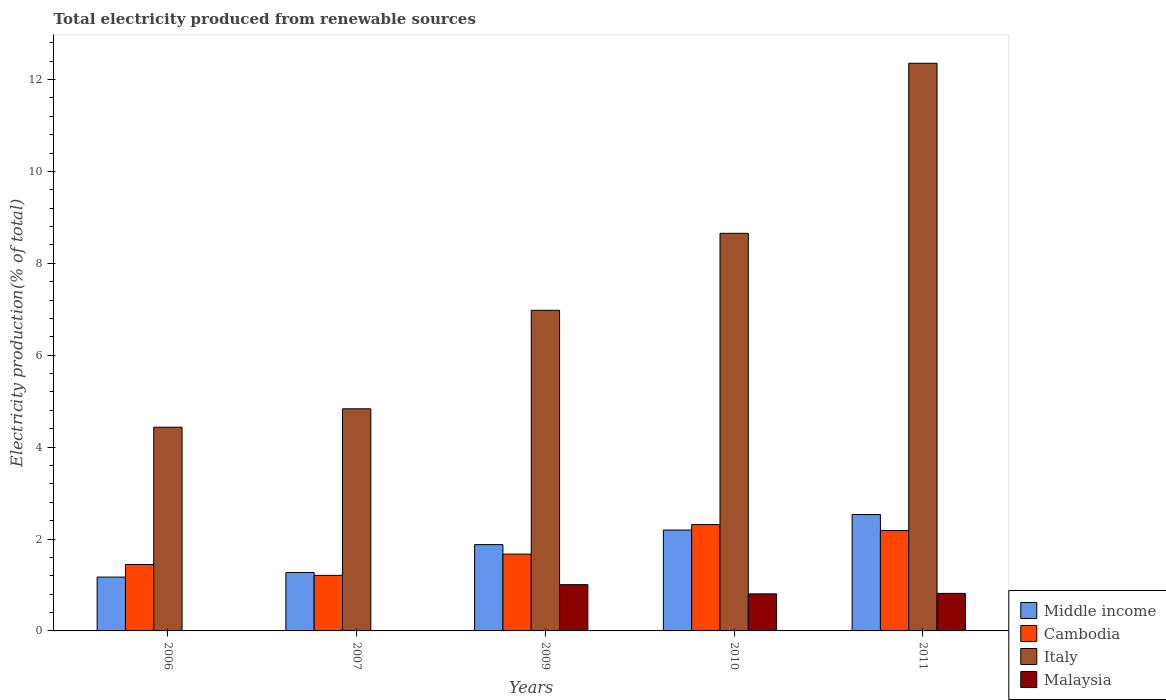How many different coloured bars are there?
Keep it short and to the point. 4. Are the number of bars on each tick of the X-axis equal?
Your answer should be very brief. Yes. How many bars are there on the 4th tick from the right?
Offer a terse response. 4. In how many cases, is the number of bars for a given year not equal to the number of legend labels?
Give a very brief answer. 0. What is the total electricity produced in Italy in 2010?
Offer a very short reply. 8.65. Across all years, what is the maximum total electricity produced in Italy?
Make the answer very short. 12.35. Across all years, what is the minimum total electricity produced in Malaysia?
Offer a terse response. 0. In which year was the total electricity produced in Middle income maximum?
Your answer should be compact. 2011. In which year was the total electricity produced in Cambodia minimum?
Your answer should be compact. 2007. What is the total total electricity produced in Italy in the graph?
Ensure brevity in your answer.  37.25. What is the difference between the total electricity produced in Malaysia in 2006 and that in 2009?
Offer a terse response. -1.01. What is the difference between the total electricity produced in Italy in 2011 and the total electricity produced in Cambodia in 2007?
Keep it short and to the point. 11.14. What is the average total electricity produced in Malaysia per year?
Give a very brief answer. 0.53. In the year 2009, what is the difference between the total electricity produced in Middle income and total electricity produced in Malaysia?
Give a very brief answer. 0.87. In how many years, is the total electricity produced in Middle income greater than 9.6 %?
Give a very brief answer. 0. What is the ratio of the total electricity produced in Cambodia in 2006 to that in 2010?
Provide a succinct answer. 0.62. Is the total electricity produced in Cambodia in 2009 less than that in 2010?
Your answer should be compact. Yes. What is the difference between the highest and the second highest total electricity produced in Middle income?
Offer a very short reply. 0.34. What is the difference between the highest and the lowest total electricity produced in Italy?
Give a very brief answer. 7.92. Is it the case that in every year, the sum of the total electricity produced in Italy and total electricity produced in Middle income is greater than the sum of total electricity produced in Malaysia and total electricity produced in Cambodia?
Your response must be concise. Yes. What does the 2nd bar from the left in 2006 represents?
Make the answer very short. Cambodia. What does the 4th bar from the right in 2007 represents?
Your answer should be very brief. Middle income. Is it the case that in every year, the sum of the total electricity produced in Middle income and total electricity produced in Italy is greater than the total electricity produced in Cambodia?
Provide a succinct answer. Yes. How many bars are there?
Offer a very short reply. 20. Are all the bars in the graph horizontal?
Offer a terse response. No. How many years are there in the graph?
Provide a succinct answer. 5. What is the difference between two consecutive major ticks on the Y-axis?
Provide a succinct answer. 2. Does the graph contain grids?
Your answer should be very brief. No. How many legend labels are there?
Your answer should be compact. 4. How are the legend labels stacked?
Your answer should be very brief. Vertical. What is the title of the graph?
Ensure brevity in your answer.  Total electricity produced from renewable sources. Does "Cote d'Ivoire" appear as one of the legend labels in the graph?
Offer a terse response. No. What is the Electricity production(% of total) in Middle income in 2006?
Offer a very short reply. 1.17. What is the Electricity production(% of total) of Cambodia in 2006?
Your response must be concise. 1.45. What is the Electricity production(% of total) of Italy in 2006?
Offer a terse response. 4.43. What is the Electricity production(% of total) of Malaysia in 2006?
Your answer should be very brief. 0. What is the Electricity production(% of total) in Middle income in 2007?
Keep it short and to the point. 1.27. What is the Electricity production(% of total) of Cambodia in 2007?
Your answer should be very brief. 1.21. What is the Electricity production(% of total) of Italy in 2007?
Keep it short and to the point. 4.83. What is the Electricity production(% of total) in Malaysia in 2007?
Make the answer very short. 0. What is the Electricity production(% of total) of Middle income in 2009?
Your response must be concise. 1.88. What is the Electricity production(% of total) in Cambodia in 2009?
Your response must be concise. 1.67. What is the Electricity production(% of total) of Italy in 2009?
Your response must be concise. 6.98. What is the Electricity production(% of total) of Malaysia in 2009?
Give a very brief answer. 1.01. What is the Electricity production(% of total) in Middle income in 2010?
Your answer should be compact. 2.2. What is the Electricity production(% of total) of Cambodia in 2010?
Provide a succinct answer. 2.31. What is the Electricity production(% of total) of Italy in 2010?
Offer a very short reply. 8.65. What is the Electricity production(% of total) of Malaysia in 2010?
Your answer should be very brief. 0.81. What is the Electricity production(% of total) in Middle income in 2011?
Your answer should be very brief. 2.53. What is the Electricity production(% of total) of Cambodia in 2011?
Provide a short and direct response. 2.18. What is the Electricity production(% of total) in Italy in 2011?
Provide a succinct answer. 12.35. What is the Electricity production(% of total) of Malaysia in 2011?
Your answer should be compact. 0.82. Across all years, what is the maximum Electricity production(% of total) in Middle income?
Offer a terse response. 2.53. Across all years, what is the maximum Electricity production(% of total) in Cambodia?
Ensure brevity in your answer.  2.31. Across all years, what is the maximum Electricity production(% of total) in Italy?
Your answer should be very brief. 12.35. Across all years, what is the maximum Electricity production(% of total) of Malaysia?
Your answer should be very brief. 1.01. Across all years, what is the minimum Electricity production(% of total) of Middle income?
Your response must be concise. 1.17. Across all years, what is the minimum Electricity production(% of total) of Cambodia?
Offer a very short reply. 1.21. Across all years, what is the minimum Electricity production(% of total) of Italy?
Offer a very short reply. 4.43. Across all years, what is the minimum Electricity production(% of total) in Malaysia?
Your answer should be compact. 0. What is the total Electricity production(% of total) in Middle income in the graph?
Provide a succinct answer. 9.05. What is the total Electricity production(% of total) in Cambodia in the graph?
Provide a short and direct response. 8.82. What is the total Electricity production(% of total) in Italy in the graph?
Ensure brevity in your answer.  37.25. What is the total Electricity production(% of total) in Malaysia in the graph?
Offer a very short reply. 2.63. What is the difference between the Electricity production(% of total) of Middle income in 2006 and that in 2007?
Provide a succinct answer. -0.1. What is the difference between the Electricity production(% of total) in Cambodia in 2006 and that in 2007?
Offer a terse response. 0.24. What is the difference between the Electricity production(% of total) in Italy in 2006 and that in 2007?
Keep it short and to the point. -0.4. What is the difference between the Electricity production(% of total) of Malaysia in 2006 and that in 2007?
Offer a terse response. 0. What is the difference between the Electricity production(% of total) in Middle income in 2006 and that in 2009?
Your response must be concise. -0.71. What is the difference between the Electricity production(% of total) in Cambodia in 2006 and that in 2009?
Your answer should be very brief. -0.23. What is the difference between the Electricity production(% of total) of Italy in 2006 and that in 2009?
Keep it short and to the point. -2.54. What is the difference between the Electricity production(% of total) in Malaysia in 2006 and that in 2009?
Ensure brevity in your answer.  -1.01. What is the difference between the Electricity production(% of total) of Middle income in 2006 and that in 2010?
Provide a succinct answer. -1.02. What is the difference between the Electricity production(% of total) in Cambodia in 2006 and that in 2010?
Give a very brief answer. -0.87. What is the difference between the Electricity production(% of total) in Italy in 2006 and that in 2010?
Your response must be concise. -4.22. What is the difference between the Electricity production(% of total) in Malaysia in 2006 and that in 2010?
Your answer should be compact. -0.81. What is the difference between the Electricity production(% of total) of Middle income in 2006 and that in 2011?
Give a very brief answer. -1.36. What is the difference between the Electricity production(% of total) in Cambodia in 2006 and that in 2011?
Provide a succinct answer. -0.74. What is the difference between the Electricity production(% of total) of Italy in 2006 and that in 2011?
Your answer should be compact. -7.92. What is the difference between the Electricity production(% of total) in Malaysia in 2006 and that in 2011?
Offer a very short reply. -0.82. What is the difference between the Electricity production(% of total) in Middle income in 2007 and that in 2009?
Offer a very short reply. -0.61. What is the difference between the Electricity production(% of total) of Cambodia in 2007 and that in 2009?
Make the answer very short. -0.46. What is the difference between the Electricity production(% of total) in Italy in 2007 and that in 2009?
Give a very brief answer. -2.14. What is the difference between the Electricity production(% of total) in Malaysia in 2007 and that in 2009?
Give a very brief answer. -1.01. What is the difference between the Electricity production(% of total) in Middle income in 2007 and that in 2010?
Make the answer very short. -0.92. What is the difference between the Electricity production(% of total) in Cambodia in 2007 and that in 2010?
Your response must be concise. -1.1. What is the difference between the Electricity production(% of total) of Italy in 2007 and that in 2010?
Make the answer very short. -3.82. What is the difference between the Electricity production(% of total) of Malaysia in 2007 and that in 2010?
Your response must be concise. -0.81. What is the difference between the Electricity production(% of total) in Middle income in 2007 and that in 2011?
Provide a succinct answer. -1.26. What is the difference between the Electricity production(% of total) of Cambodia in 2007 and that in 2011?
Your response must be concise. -0.98. What is the difference between the Electricity production(% of total) of Italy in 2007 and that in 2011?
Give a very brief answer. -7.52. What is the difference between the Electricity production(% of total) of Malaysia in 2007 and that in 2011?
Your response must be concise. -0.82. What is the difference between the Electricity production(% of total) in Middle income in 2009 and that in 2010?
Offer a very short reply. -0.32. What is the difference between the Electricity production(% of total) in Cambodia in 2009 and that in 2010?
Offer a very short reply. -0.64. What is the difference between the Electricity production(% of total) in Italy in 2009 and that in 2010?
Provide a short and direct response. -1.67. What is the difference between the Electricity production(% of total) of Malaysia in 2009 and that in 2010?
Ensure brevity in your answer.  0.2. What is the difference between the Electricity production(% of total) of Middle income in 2009 and that in 2011?
Keep it short and to the point. -0.65. What is the difference between the Electricity production(% of total) in Cambodia in 2009 and that in 2011?
Offer a terse response. -0.51. What is the difference between the Electricity production(% of total) in Italy in 2009 and that in 2011?
Provide a succinct answer. -5.38. What is the difference between the Electricity production(% of total) in Malaysia in 2009 and that in 2011?
Make the answer very short. 0.19. What is the difference between the Electricity production(% of total) of Middle income in 2010 and that in 2011?
Provide a succinct answer. -0.34. What is the difference between the Electricity production(% of total) of Cambodia in 2010 and that in 2011?
Give a very brief answer. 0.13. What is the difference between the Electricity production(% of total) in Italy in 2010 and that in 2011?
Your answer should be compact. -3.7. What is the difference between the Electricity production(% of total) in Malaysia in 2010 and that in 2011?
Ensure brevity in your answer.  -0.01. What is the difference between the Electricity production(% of total) of Middle income in 2006 and the Electricity production(% of total) of Cambodia in 2007?
Provide a short and direct response. -0.04. What is the difference between the Electricity production(% of total) in Middle income in 2006 and the Electricity production(% of total) in Italy in 2007?
Your answer should be compact. -3.66. What is the difference between the Electricity production(% of total) of Middle income in 2006 and the Electricity production(% of total) of Malaysia in 2007?
Offer a very short reply. 1.17. What is the difference between the Electricity production(% of total) of Cambodia in 2006 and the Electricity production(% of total) of Italy in 2007?
Offer a very short reply. -3.39. What is the difference between the Electricity production(% of total) in Cambodia in 2006 and the Electricity production(% of total) in Malaysia in 2007?
Your answer should be compact. 1.44. What is the difference between the Electricity production(% of total) in Italy in 2006 and the Electricity production(% of total) in Malaysia in 2007?
Ensure brevity in your answer.  4.43. What is the difference between the Electricity production(% of total) in Middle income in 2006 and the Electricity production(% of total) in Cambodia in 2009?
Provide a succinct answer. -0.5. What is the difference between the Electricity production(% of total) of Middle income in 2006 and the Electricity production(% of total) of Italy in 2009?
Keep it short and to the point. -5.81. What is the difference between the Electricity production(% of total) of Middle income in 2006 and the Electricity production(% of total) of Malaysia in 2009?
Keep it short and to the point. 0.16. What is the difference between the Electricity production(% of total) of Cambodia in 2006 and the Electricity production(% of total) of Italy in 2009?
Give a very brief answer. -5.53. What is the difference between the Electricity production(% of total) in Cambodia in 2006 and the Electricity production(% of total) in Malaysia in 2009?
Your answer should be very brief. 0.44. What is the difference between the Electricity production(% of total) in Italy in 2006 and the Electricity production(% of total) in Malaysia in 2009?
Ensure brevity in your answer.  3.43. What is the difference between the Electricity production(% of total) of Middle income in 2006 and the Electricity production(% of total) of Cambodia in 2010?
Give a very brief answer. -1.14. What is the difference between the Electricity production(% of total) of Middle income in 2006 and the Electricity production(% of total) of Italy in 2010?
Your answer should be very brief. -7.48. What is the difference between the Electricity production(% of total) of Middle income in 2006 and the Electricity production(% of total) of Malaysia in 2010?
Give a very brief answer. 0.37. What is the difference between the Electricity production(% of total) of Cambodia in 2006 and the Electricity production(% of total) of Italy in 2010?
Keep it short and to the point. -7.21. What is the difference between the Electricity production(% of total) of Cambodia in 2006 and the Electricity production(% of total) of Malaysia in 2010?
Your answer should be very brief. 0.64. What is the difference between the Electricity production(% of total) in Italy in 2006 and the Electricity production(% of total) in Malaysia in 2010?
Your response must be concise. 3.63. What is the difference between the Electricity production(% of total) of Middle income in 2006 and the Electricity production(% of total) of Cambodia in 2011?
Provide a short and direct response. -1.01. What is the difference between the Electricity production(% of total) of Middle income in 2006 and the Electricity production(% of total) of Italy in 2011?
Give a very brief answer. -11.18. What is the difference between the Electricity production(% of total) in Middle income in 2006 and the Electricity production(% of total) in Malaysia in 2011?
Give a very brief answer. 0.35. What is the difference between the Electricity production(% of total) of Cambodia in 2006 and the Electricity production(% of total) of Italy in 2011?
Make the answer very short. -10.91. What is the difference between the Electricity production(% of total) in Cambodia in 2006 and the Electricity production(% of total) in Malaysia in 2011?
Offer a very short reply. 0.63. What is the difference between the Electricity production(% of total) of Italy in 2006 and the Electricity production(% of total) of Malaysia in 2011?
Your answer should be very brief. 3.62. What is the difference between the Electricity production(% of total) of Middle income in 2007 and the Electricity production(% of total) of Cambodia in 2009?
Make the answer very short. -0.4. What is the difference between the Electricity production(% of total) of Middle income in 2007 and the Electricity production(% of total) of Italy in 2009?
Keep it short and to the point. -5.71. What is the difference between the Electricity production(% of total) of Middle income in 2007 and the Electricity production(% of total) of Malaysia in 2009?
Provide a short and direct response. 0.26. What is the difference between the Electricity production(% of total) in Cambodia in 2007 and the Electricity production(% of total) in Italy in 2009?
Offer a very short reply. -5.77. What is the difference between the Electricity production(% of total) in Cambodia in 2007 and the Electricity production(% of total) in Malaysia in 2009?
Your answer should be very brief. 0.2. What is the difference between the Electricity production(% of total) of Italy in 2007 and the Electricity production(% of total) of Malaysia in 2009?
Your response must be concise. 3.83. What is the difference between the Electricity production(% of total) in Middle income in 2007 and the Electricity production(% of total) in Cambodia in 2010?
Provide a short and direct response. -1.04. What is the difference between the Electricity production(% of total) of Middle income in 2007 and the Electricity production(% of total) of Italy in 2010?
Make the answer very short. -7.38. What is the difference between the Electricity production(% of total) in Middle income in 2007 and the Electricity production(% of total) in Malaysia in 2010?
Your answer should be compact. 0.47. What is the difference between the Electricity production(% of total) of Cambodia in 2007 and the Electricity production(% of total) of Italy in 2010?
Offer a terse response. -7.44. What is the difference between the Electricity production(% of total) of Cambodia in 2007 and the Electricity production(% of total) of Malaysia in 2010?
Offer a very short reply. 0.4. What is the difference between the Electricity production(% of total) in Italy in 2007 and the Electricity production(% of total) in Malaysia in 2010?
Offer a very short reply. 4.03. What is the difference between the Electricity production(% of total) in Middle income in 2007 and the Electricity production(% of total) in Cambodia in 2011?
Ensure brevity in your answer.  -0.91. What is the difference between the Electricity production(% of total) of Middle income in 2007 and the Electricity production(% of total) of Italy in 2011?
Your response must be concise. -11.08. What is the difference between the Electricity production(% of total) of Middle income in 2007 and the Electricity production(% of total) of Malaysia in 2011?
Your answer should be compact. 0.45. What is the difference between the Electricity production(% of total) of Cambodia in 2007 and the Electricity production(% of total) of Italy in 2011?
Offer a terse response. -11.14. What is the difference between the Electricity production(% of total) of Cambodia in 2007 and the Electricity production(% of total) of Malaysia in 2011?
Offer a terse response. 0.39. What is the difference between the Electricity production(% of total) of Italy in 2007 and the Electricity production(% of total) of Malaysia in 2011?
Offer a very short reply. 4.02. What is the difference between the Electricity production(% of total) in Middle income in 2009 and the Electricity production(% of total) in Cambodia in 2010?
Make the answer very short. -0.44. What is the difference between the Electricity production(% of total) of Middle income in 2009 and the Electricity production(% of total) of Italy in 2010?
Your response must be concise. -6.77. What is the difference between the Electricity production(% of total) in Middle income in 2009 and the Electricity production(% of total) in Malaysia in 2010?
Provide a succinct answer. 1.07. What is the difference between the Electricity production(% of total) in Cambodia in 2009 and the Electricity production(% of total) in Italy in 2010?
Provide a short and direct response. -6.98. What is the difference between the Electricity production(% of total) of Cambodia in 2009 and the Electricity production(% of total) of Malaysia in 2010?
Make the answer very short. 0.87. What is the difference between the Electricity production(% of total) in Italy in 2009 and the Electricity production(% of total) in Malaysia in 2010?
Keep it short and to the point. 6.17. What is the difference between the Electricity production(% of total) of Middle income in 2009 and the Electricity production(% of total) of Cambodia in 2011?
Give a very brief answer. -0.31. What is the difference between the Electricity production(% of total) of Middle income in 2009 and the Electricity production(% of total) of Italy in 2011?
Provide a succinct answer. -10.47. What is the difference between the Electricity production(% of total) of Middle income in 2009 and the Electricity production(% of total) of Malaysia in 2011?
Your answer should be compact. 1.06. What is the difference between the Electricity production(% of total) of Cambodia in 2009 and the Electricity production(% of total) of Italy in 2011?
Make the answer very short. -10.68. What is the difference between the Electricity production(% of total) in Cambodia in 2009 and the Electricity production(% of total) in Malaysia in 2011?
Keep it short and to the point. 0.86. What is the difference between the Electricity production(% of total) in Italy in 2009 and the Electricity production(% of total) in Malaysia in 2011?
Offer a very short reply. 6.16. What is the difference between the Electricity production(% of total) in Middle income in 2010 and the Electricity production(% of total) in Cambodia in 2011?
Provide a succinct answer. 0.01. What is the difference between the Electricity production(% of total) of Middle income in 2010 and the Electricity production(% of total) of Italy in 2011?
Provide a succinct answer. -10.16. What is the difference between the Electricity production(% of total) of Middle income in 2010 and the Electricity production(% of total) of Malaysia in 2011?
Offer a very short reply. 1.38. What is the difference between the Electricity production(% of total) of Cambodia in 2010 and the Electricity production(% of total) of Italy in 2011?
Give a very brief answer. -10.04. What is the difference between the Electricity production(% of total) in Cambodia in 2010 and the Electricity production(% of total) in Malaysia in 2011?
Offer a terse response. 1.5. What is the difference between the Electricity production(% of total) of Italy in 2010 and the Electricity production(% of total) of Malaysia in 2011?
Your answer should be compact. 7.84. What is the average Electricity production(% of total) in Middle income per year?
Your answer should be compact. 1.81. What is the average Electricity production(% of total) in Cambodia per year?
Your answer should be compact. 1.76. What is the average Electricity production(% of total) in Italy per year?
Offer a terse response. 7.45. What is the average Electricity production(% of total) of Malaysia per year?
Give a very brief answer. 0.53. In the year 2006, what is the difference between the Electricity production(% of total) in Middle income and Electricity production(% of total) in Cambodia?
Make the answer very short. -0.27. In the year 2006, what is the difference between the Electricity production(% of total) of Middle income and Electricity production(% of total) of Italy?
Offer a very short reply. -3.26. In the year 2006, what is the difference between the Electricity production(% of total) of Middle income and Electricity production(% of total) of Malaysia?
Your answer should be compact. 1.17. In the year 2006, what is the difference between the Electricity production(% of total) in Cambodia and Electricity production(% of total) in Italy?
Offer a very short reply. -2.99. In the year 2006, what is the difference between the Electricity production(% of total) of Cambodia and Electricity production(% of total) of Malaysia?
Make the answer very short. 1.44. In the year 2006, what is the difference between the Electricity production(% of total) of Italy and Electricity production(% of total) of Malaysia?
Your answer should be compact. 4.43. In the year 2007, what is the difference between the Electricity production(% of total) of Middle income and Electricity production(% of total) of Cambodia?
Provide a succinct answer. 0.06. In the year 2007, what is the difference between the Electricity production(% of total) of Middle income and Electricity production(% of total) of Italy?
Give a very brief answer. -3.56. In the year 2007, what is the difference between the Electricity production(% of total) in Middle income and Electricity production(% of total) in Malaysia?
Give a very brief answer. 1.27. In the year 2007, what is the difference between the Electricity production(% of total) in Cambodia and Electricity production(% of total) in Italy?
Give a very brief answer. -3.62. In the year 2007, what is the difference between the Electricity production(% of total) of Cambodia and Electricity production(% of total) of Malaysia?
Your answer should be very brief. 1.21. In the year 2007, what is the difference between the Electricity production(% of total) in Italy and Electricity production(% of total) in Malaysia?
Provide a short and direct response. 4.83. In the year 2009, what is the difference between the Electricity production(% of total) in Middle income and Electricity production(% of total) in Cambodia?
Your answer should be very brief. 0.21. In the year 2009, what is the difference between the Electricity production(% of total) of Middle income and Electricity production(% of total) of Italy?
Provide a succinct answer. -5.1. In the year 2009, what is the difference between the Electricity production(% of total) in Middle income and Electricity production(% of total) in Malaysia?
Provide a succinct answer. 0.87. In the year 2009, what is the difference between the Electricity production(% of total) in Cambodia and Electricity production(% of total) in Italy?
Give a very brief answer. -5.31. In the year 2009, what is the difference between the Electricity production(% of total) of Cambodia and Electricity production(% of total) of Malaysia?
Give a very brief answer. 0.67. In the year 2009, what is the difference between the Electricity production(% of total) in Italy and Electricity production(% of total) in Malaysia?
Your answer should be very brief. 5.97. In the year 2010, what is the difference between the Electricity production(% of total) in Middle income and Electricity production(% of total) in Cambodia?
Offer a very short reply. -0.12. In the year 2010, what is the difference between the Electricity production(% of total) in Middle income and Electricity production(% of total) in Italy?
Your response must be concise. -6.46. In the year 2010, what is the difference between the Electricity production(% of total) of Middle income and Electricity production(% of total) of Malaysia?
Your answer should be compact. 1.39. In the year 2010, what is the difference between the Electricity production(% of total) of Cambodia and Electricity production(% of total) of Italy?
Provide a succinct answer. -6.34. In the year 2010, what is the difference between the Electricity production(% of total) of Cambodia and Electricity production(% of total) of Malaysia?
Keep it short and to the point. 1.51. In the year 2010, what is the difference between the Electricity production(% of total) in Italy and Electricity production(% of total) in Malaysia?
Make the answer very short. 7.85. In the year 2011, what is the difference between the Electricity production(% of total) in Middle income and Electricity production(% of total) in Cambodia?
Provide a succinct answer. 0.35. In the year 2011, what is the difference between the Electricity production(% of total) in Middle income and Electricity production(% of total) in Italy?
Your answer should be compact. -9.82. In the year 2011, what is the difference between the Electricity production(% of total) in Middle income and Electricity production(% of total) in Malaysia?
Keep it short and to the point. 1.72. In the year 2011, what is the difference between the Electricity production(% of total) of Cambodia and Electricity production(% of total) of Italy?
Keep it short and to the point. -10.17. In the year 2011, what is the difference between the Electricity production(% of total) of Cambodia and Electricity production(% of total) of Malaysia?
Provide a succinct answer. 1.37. In the year 2011, what is the difference between the Electricity production(% of total) of Italy and Electricity production(% of total) of Malaysia?
Keep it short and to the point. 11.54. What is the ratio of the Electricity production(% of total) of Middle income in 2006 to that in 2007?
Make the answer very short. 0.92. What is the ratio of the Electricity production(% of total) in Cambodia in 2006 to that in 2007?
Make the answer very short. 1.2. What is the ratio of the Electricity production(% of total) of Italy in 2006 to that in 2007?
Provide a short and direct response. 0.92. What is the ratio of the Electricity production(% of total) of Malaysia in 2006 to that in 2007?
Your answer should be compact. 1.09. What is the ratio of the Electricity production(% of total) of Middle income in 2006 to that in 2009?
Your answer should be compact. 0.62. What is the ratio of the Electricity production(% of total) of Cambodia in 2006 to that in 2009?
Offer a terse response. 0.86. What is the ratio of the Electricity production(% of total) of Italy in 2006 to that in 2009?
Provide a short and direct response. 0.64. What is the ratio of the Electricity production(% of total) in Malaysia in 2006 to that in 2009?
Your answer should be very brief. 0. What is the ratio of the Electricity production(% of total) of Middle income in 2006 to that in 2010?
Your answer should be compact. 0.53. What is the ratio of the Electricity production(% of total) of Cambodia in 2006 to that in 2010?
Make the answer very short. 0.62. What is the ratio of the Electricity production(% of total) of Italy in 2006 to that in 2010?
Offer a very short reply. 0.51. What is the ratio of the Electricity production(% of total) of Malaysia in 2006 to that in 2010?
Provide a succinct answer. 0. What is the ratio of the Electricity production(% of total) in Middle income in 2006 to that in 2011?
Give a very brief answer. 0.46. What is the ratio of the Electricity production(% of total) in Cambodia in 2006 to that in 2011?
Offer a very short reply. 0.66. What is the ratio of the Electricity production(% of total) in Italy in 2006 to that in 2011?
Your answer should be very brief. 0.36. What is the ratio of the Electricity production(% of total) in Malaysia in 2006 to that in 2011?
Your answer should be very brief. 0. What is the ratio of the Electricity production(% of total) of Middle income in 2007 to that in 2009?
Ensure brevity in your answer.  0.68. What is the ratio of the Electricity production(% of total) of Cambodia in 2007 to that in 2009?
Your answer should be very brief. 0.72. What is the ratio of the Electricity production(% of total) of Italy in 2007 to that in 2009?
Offer a terse response. 0.69. What is the ratio of the Electricity production(% of total) in Malaysia in 2007 to that in 2009?
Make the answer very short. 0. What is the ratio of the Electricity production(% of total) of Middle income in 2007 to that in 2010?
Provide a short and direct response. 0.58. What is the ratio of the Electricity production(% of total) of Cambodia in 2007 to that in 2010?
Your answer should be compact. 0.52. What is the ratio of the Electricity production(% of total) in Italy in 2007 to that in 2010?
Offer a terse response. 0.56. What is the ratio of the Electricity production(% of total) in Malaysia in 2007 to that in 2010?
Provide a short and direct response. 0. What is the ratio of the Electricity production(% of total) of Middle income in 2007 to that in 2011?
Your response must be concise. 0.5. What is the ratio of the Electricity production(% of total) of Cambodia in 2007 to that in 2011?
Offer a terse response. 0.55. What is the ratio of the Electricity production(% of total) of Italy in 2007 to that in 2011?
Ensure brevity in your answer.  0.39. What is the ratio of the Electricity production(% of total) of Malaysia in 2007 to that in 2011?
Make the answer very short. 0. What is the ratio of the Electricity production(% of total) in Middle income in 2009 to that in 2010?
Offer a terse response. 0.86. What is the ratio of the Electricity production(% of total) of Cambodia in 2009 to that in 2010?
Provide a short and direct response. 0.72. What is the ratio of the Electricity production(% of total) of Italy in 2009 to that in 2010?
Ensure brevity in your answer.  0.81. What is the ratio of the Electricity production(% of total) in Malaysia in 2009 to that in 2010?
Make the answer very short. 1.25. What is the ratio of the Electricity production(% of total) in Middle income in 2009 to that in 2011?
Keep it short and to the point. 0.74. What is the ratio of the Electricity production(% of total) in Cambodia in 2009 to that in 2011?
Keep it short and to the point. 0.77. What is the ratio of the Electricity production(% of total) in Italy in 2009 to that in 2011?
Provide a succinct answer. 0.56. What is the ratio of the Electricity production(% of total) of Malaysia in 2009 to that in 2011?
Keep it short and to the point. 1.23. What is the ratio of the Electricity production(% of total) of Middle income in 2010 to that in 2011?
Provide a succinct answer. 0.87. What is the ratio of the Electricity production(% of total) in Cambodia in 2010 to that in 2011?
Your response must be concise. 1.06. What is the ratio of the Electricity production(% of total) of Italy in 2010 to that in 2011?
Offer a very short reply. 0.7. What is the ratio of the Electricity production(% of total) of Malaysia in 2010 to that in 2011?
Offer a very short reply. 0.99. What is the difference between the highest and the second highest Electricity production(% of total) of Middle income?
Your response must be concise. 0.34. What is the difference between the highest and the second highest Electricity production(% of total) in Cambodia?
Your response must be concise. 0.13. What is the difference between the highest and the second highest Electricity production(% of total) of Italy?
Your answer should be compact. 3.7. What is the difference between the highest and the second highest Electricity production(% of total) in Malaysia?
Make the answer very short. 0.19. What is the difference between the highest and the lowest Electricity production(% of total) in Middle income?
Offer a very short reply. 1.36. What is the difference between the highest and the lowest Electricity production(% of total) in Cambodia?
Provide a succinct answer. 1.1. What is the difference between the highest and the lowest Electricity production(% of total) of Italy?
Your response must be concise. 7.92. 